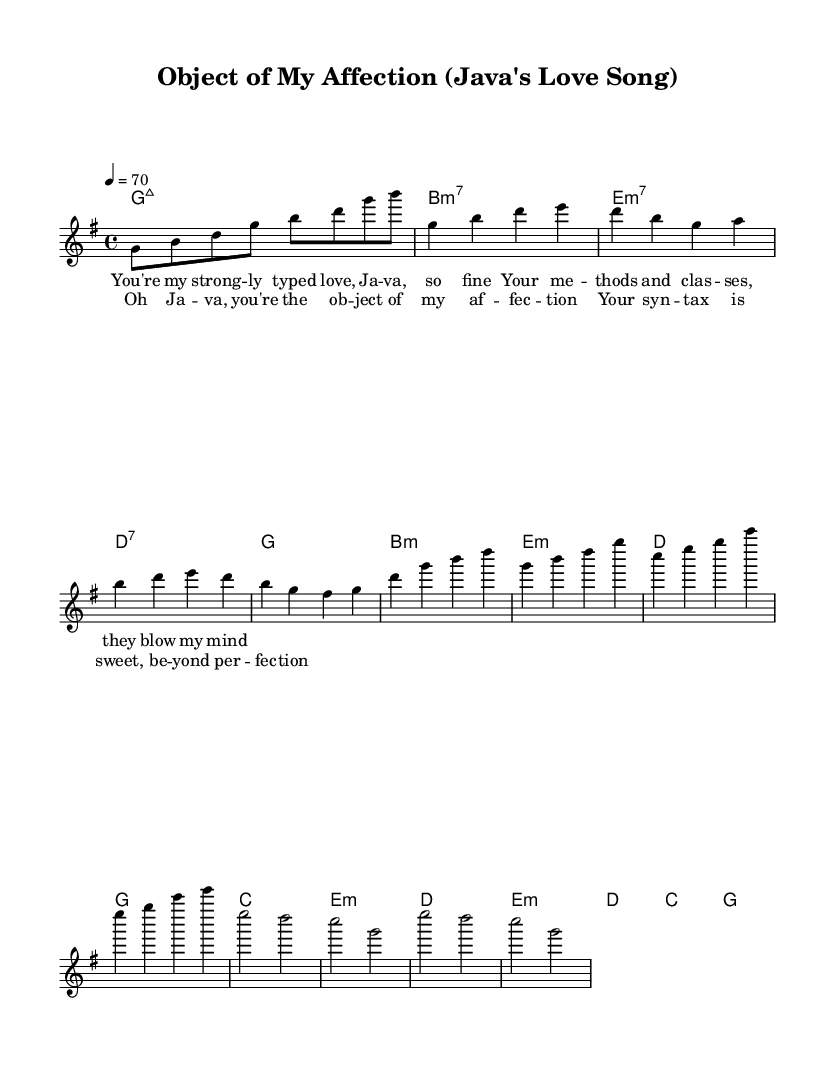What is the key signature of this music? The key signature is G major, indicated by one sharp (F#) in the context of the pitch layout throughout the piece.
Answer: G major What is the time signature of this music? The time signature is 4/4, which is evident from the initial time marking that indicates four beats per measure, making it a common rhythmic structure for R&B.
Answer: 4/4 What is the tempo marking in this score? The tempo marking is indicated as 4 equals 70, which shows the beats per minute for the piece and suggests a moderate pace typical to slower R&B ballads.
Answer: 70 How many measures are in the verse section? The verse contains four measures, as evidenced by the grouping of musical notation within the verse lyrics, representing the progression of the song's narrative.
Answer: 4 What is the main lyrical theme of the chorus? The main theme is the affection and admiration towards Java, as indicated by phrases expressing love and appreciation for its qualities, showing the emotional core of the song.
Answer: Java How are harmonies categorized in this music? Harmonies are categorized using chord symbols such as major and minor chords, which reflect the emotional undertones typical of R&B, enhancing the melodic structure with richer textures.
Answer: Major and minor What type of musical section follows the chorus? The section following the chorus is identified as the bridge, which provides a contrasting musical idea that often leads back into the chorus, enriching the emotional depth of the song.
Answer: Bridge 